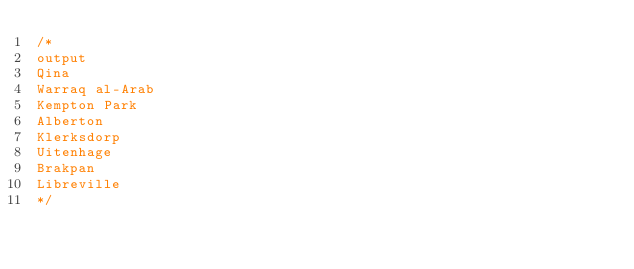Convert code to text. <code><loc_0><loc_0><loc_500><loc_500><_SQL_>/*
output
Qina 
Warraq al-Arab 
Kempton Park 
Alberton 
Klerksdorp 
Uitenhage 
Brakpan 
Libreville
*/</code> 